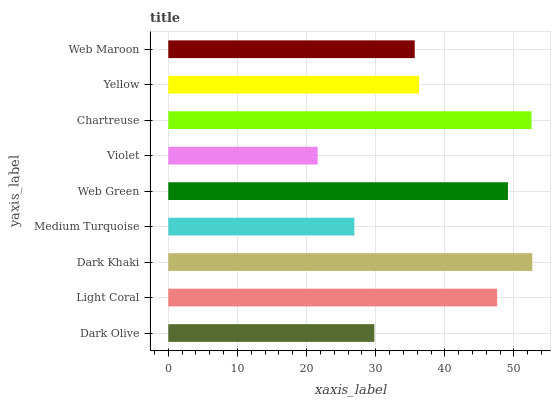Is Violet the minimum?
Answer yes or no. Yes. Is Dark Khaki the maximum?
Answer yes or no. Yes. Is Light Coral the minimum?
Answer yes or no. No. Is Light Coral the maximum?
Answer yes or no. No. Is Light Coral greater than Dark Olive?
Answer yes or no. Yes. Is Dark Olive less than Light Coral?
Answer yes or no. Yes. Is Dark Olive greater than Light Coral?
Answer yes or no. No. Is Light Coral less than Dark Olive?
Answer yes or no. No. Is Yellow the high median?
Answer yes or no. Yes. Is Yellow the low median?
Answer yes or no. Yes. Is Dark Olive the high median?
Answer yes or no. No. Is Violet the low median?
Answer yes or no. No. 